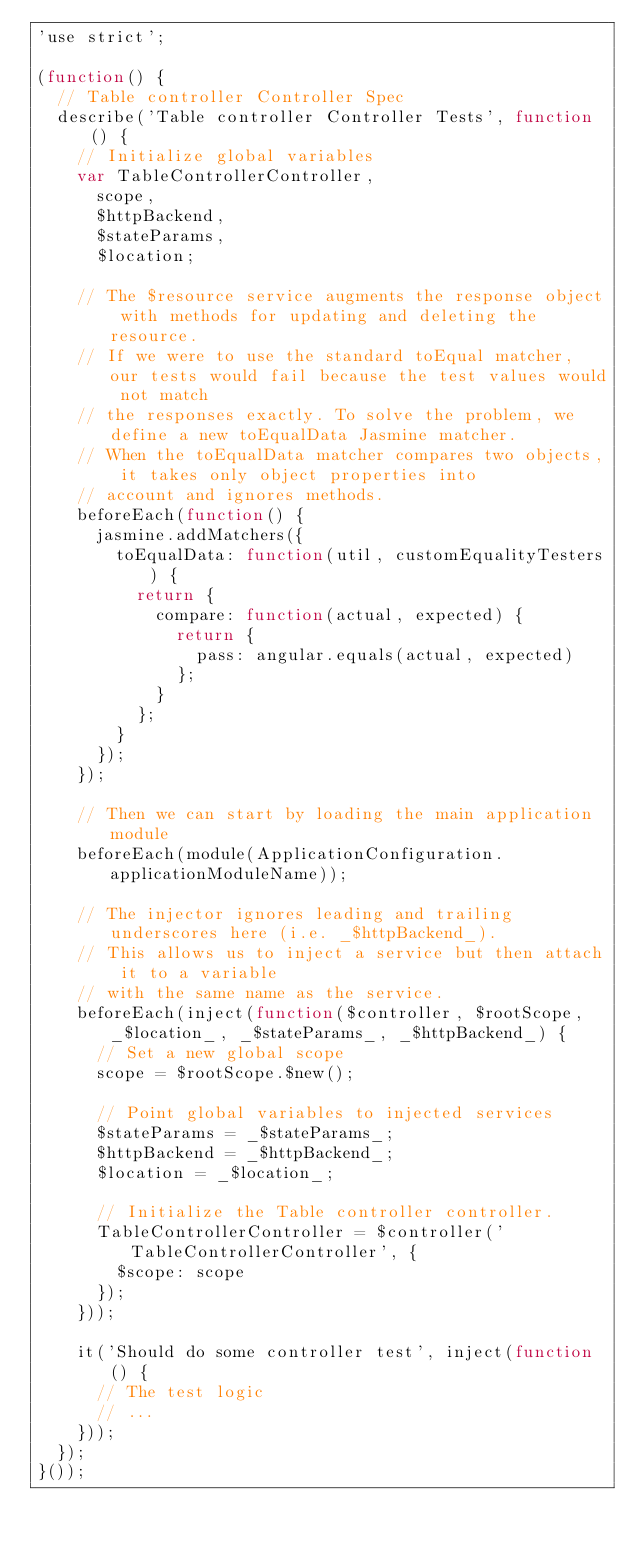<code> <loc_0><loc_0><loc_500><loc_500><_JavaScript_>'use strict';

(function() {
	// Table controller Controller Spec
	describe('Table controller Controller Tests', function() {
		// Initialize global variables
		var TableControllerController,
			scope,
			$httpBackend,
			$stateParams,
			$location;

		// The $resource service augments the response object with methods for updating and deleting the resource.
		// If we were to use the standard toEqual matcher, our tests would fail because the test values would not match
		// the responses exactly. To solve the problem, we define a new toEqualData Jasmine matcher.
		// When the toEqualData matcher compares two objects, it takes only object properties into
		// account and ignores methods.
		beforeEach(function() {
			jasmine.addMatchers({
				toEqualData: function(util, customEqualityTesters) {
					return {
						compare: function(actual, expected) {
							return {
								pass: angular.equals(actual, expected)
							};
						}
					};
				}
			});
		});

		// Then we can start by loading the main application module
		beforeEach(module(ApplicationConfiguration.applicationModuleName));

		// The injector ignores leading and trailing underscores here (i.e. _$httpBackend_).
		// This allows us to inject a service but then attach it to a variable
		// with the same name as the service.
		beforeEach(inject(function($controller, $rootScope, _$location_, _$stateParams_, _$httpBackend_) {
			// Set a new global scope
			scope = $rootScope.$new();

			// Point global variables to injected services
			$stateParams = _$stateParams_;
			$httpBackend = _$httpBackend_;
			$location = _$location_;

			// Initialize the Table controller controller.
			TableControllerController = $controller('TableControllerController', {
				$scope: scope
			});
		}));

		it('Should do some controller test', inject(function() {
			// The test logic
			// ...
		}));
	});
}());</code> 